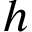<formula> <loc_0><loc_0><loc_500><loc_500>h</formula> 